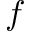<formula> <loc_0><loc_0><loc_500><loc_500>f</formula> 